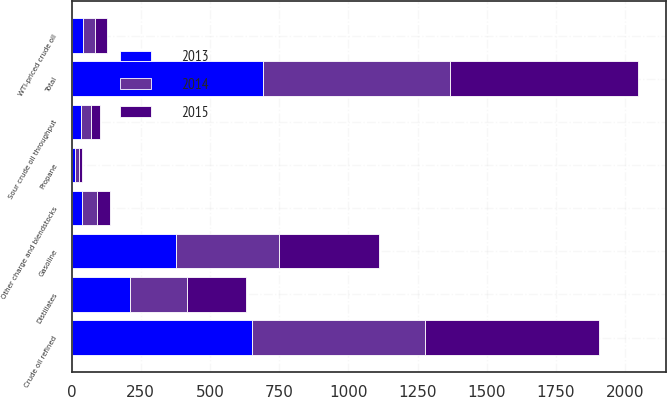Convert chart. <chart><loc_0><loc_0><loc_500><loc_500><stacked_bar_chart><ecel><fcel>Crude oil refined<fcel>Other charge and blendstocks<fcel>Total<fcel>Sour crude oil throughput<fcel>WTI-priced crude oil<fcel>Gasoline<fcel>Distillates<fcel>Propane<nl><fcel>2013<fcel>651<fcel>39<fcel>690<fcel>34<fcel>43<fcel>379<fcel>211<fcel>12<nl><fcel>2015<fcel>631<fcel>45<fcel>676<fcel>33<fcel>44<fcel>361<fcel>212<fcel>13<nl><fcel>2014<fcel>625<fcel>54<fcel>679<fcel>35<fcel>42<fcel>371<fcel>207<fcel>14<nl></chart> 